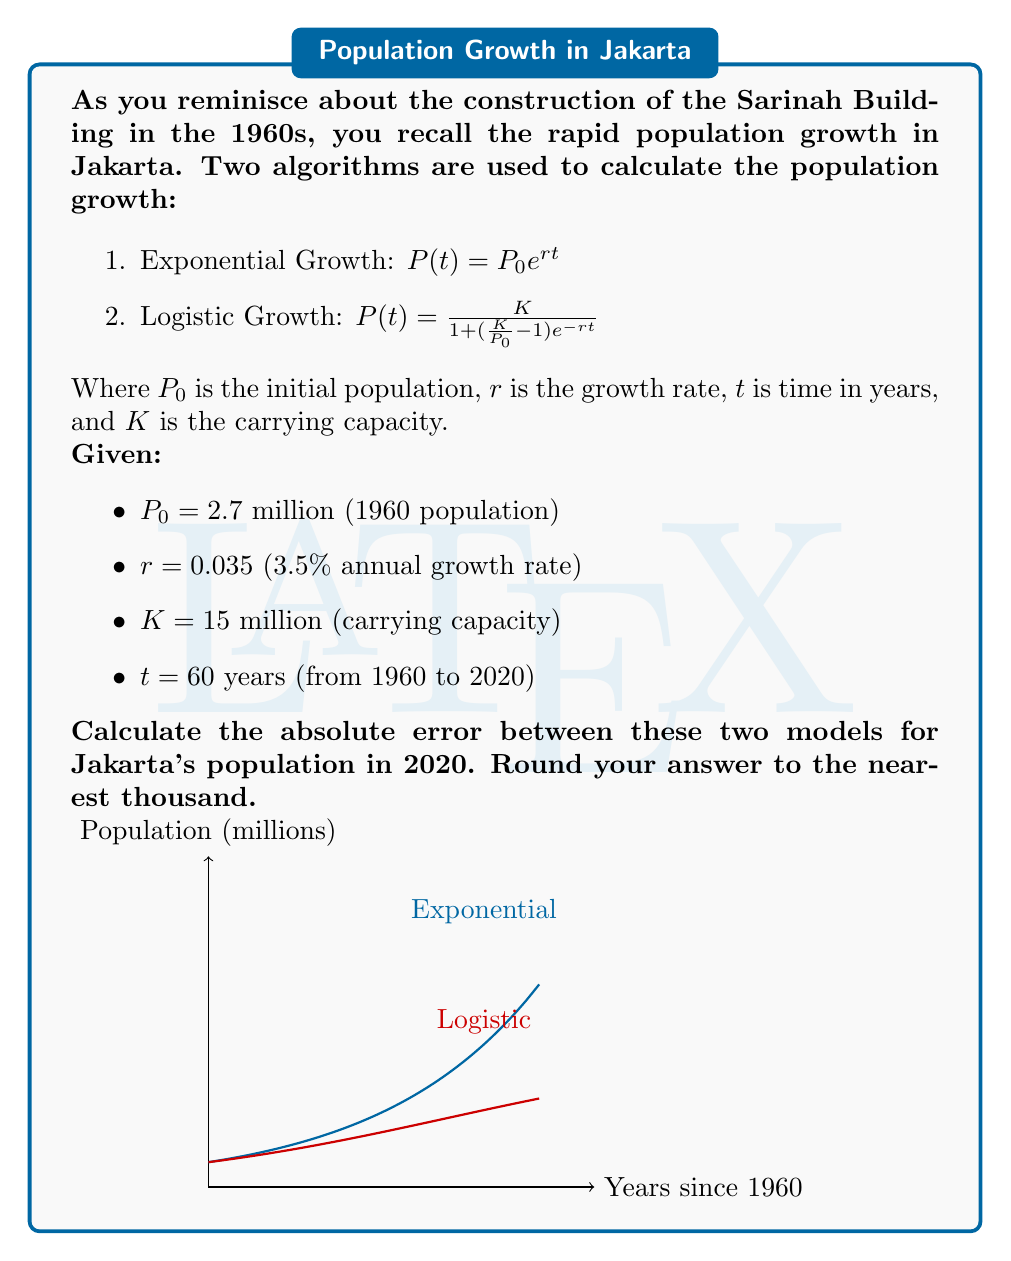Can you solve this math problem? Let's approach this step-by-step:

1) First, let's calculate the population in 2020 using the Exponential Growth model:
   $P_e(60) = 2.7 \cdot e^{0.035 \cdot 60}$
   $= 2.7 \cdot e^{2.1}$
   $= 2.7 \cdot 8.1662$
   $= 22.0487$ million

2) Now, let's calculate the population in 2020 using the Logistic Growth model:
   $P_l(60) = \frac{15}{1 + (\frac{15}{2.7} - 1)e^{-0.035 \cdot 60}}$
   $= \frac{15}{1 + 4.5556 \cdot e^{-2.1}}$
   $= \frac{15}{1 + 4.5556 \cdot 0.1225}$
   $= \frac{15}{1.5581}$
   $= 9.6272$ million

3) The absolute error is the absolute value of the difference between these two results:
   $|P_e(60) - P_l(60)| = |22.0487 - 9.6272| = 12.4215$ million

4) Rounding to the nearest thousand:
   12.4215 million ≈ 12,422,000
Answer: 12,422,000 